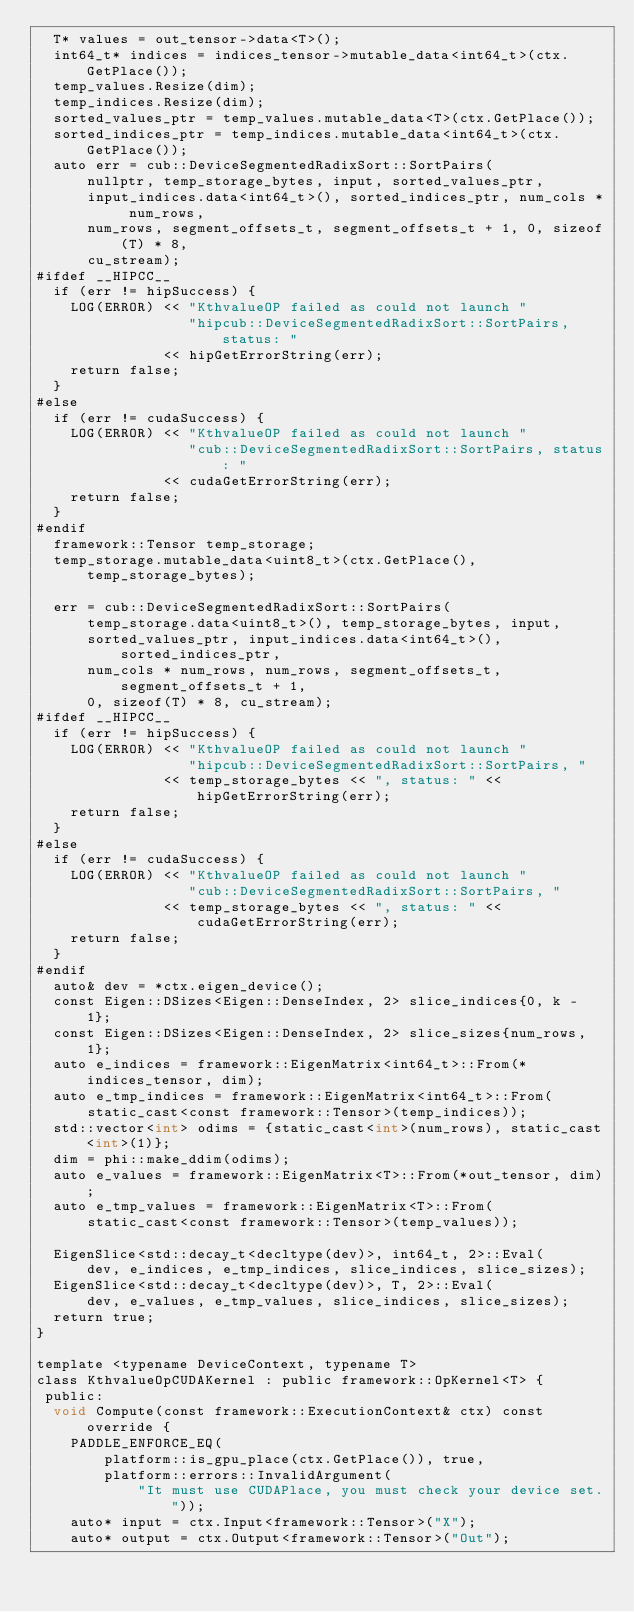<code> <loc_0><loc_0><loc_500><loc_500><_Cuda_>  T* values = out_tensor->data<T>();
  int64_t* indices = indices_tensor->mutable_data<int64_t>(ctx.GetPlace());
  temp_values.Resize(dim);
  temp_indices.Resize(dim);
  sorted_values_ptr = temp_values.mutable_data<T>(ctx.GetPlace());
  sorted_indices_ptr = temp_indices.mutable_data<int64_t>(ctx.GetPlace());
  auto err = cub::DeviceSegmentedRadixSort::SortPairs(
      nullptr, temp_storage_bytes, input, sorted_values_ptr,
      input_indices.data<int64_t>(), sorted_indices_ptr, num_cols * num_rows,
      num_rows, segment_offsets_t, segment_offsets_t + 1, 0, sizeof(T) * 8,
      cu_stream);
#ifdef __HIPCC__
  if (err != hipSuccess) {
    LOG(ERROR) << "KthvalueOP failed as could not launch "
                  "hipcub::DeviceSegmentedRadixSort::SortPairs, status: "
               << hipGetErrorString(err);
    return false;
  }
#else
  if (err != cudaSuccess) {
    LOG(ERROR) << "KthvalueOP failed as could not launch "
                  "cub::DeviceSegmentedRadixSort::SortPairs, status: "
               << cudaGetErrorString(err);
    return false;
  }
#endif
  framework::Tensor temp_storage;
  temp_storage.mutable_data<uint8_t>(ctx.GetPlace(), temp_storage_bytes);

  err = cub::DeviceSegmentedRadixSort::SortPairs(
      temp_storage.data<uint8_t>(), temp_storage_bytes, input,
      sorted_values_ptr, input_indices.data<int64_t>(), sorted_indices_ptr,
      num_cols * num_rows, num_rows, segment_offsets_t, segment_offsets_t + 1,
      0, sizeof(T) * 8, cu_stream);
#ifdef __HIPCC__
  if (err != hipSuccess) {
    LOG(ERROR) << "KthvalueOP failed as could not launch "
                  "hipcub::DeviceSegmentedRadixSort::SortPairs, "
               << temp_storage_bytes << ", status: " << hipGetErrorString(err);
    return false;
  }
#else
  if (err != cudaSuccess) {
    LOG(ERROR) << "KthvalueOP failed as could not launch "
                  "cub::DeviceSegmentedRadixSort::SortPairs, "
               << temp_storage_bytes << ", status: " << cudaGetErrorString(err);
    return false;
  }
#endif
  auto& dev = *ctx.eigen_device();
  const Eigen::DSizes<Eigen::DenseIndex, 2> slice_indices{0, k - 1};
  const Eigen::DSizes<Eigen::DenseIndex, 2> slice_sizes{num_rows, 1};
  auto e_indices = framework::EigenMatrix<int64_t>::From(*indices_tensor, dim);
  auto e_tmp_indices = framework::EigenMatrix<int64_t>::From(
      static_cast<const framework::Tensor>(temp_indices));
  std::vector<int> odims = {static_cast<int>(num_rows), static_cast<int>(1)};
  dim = phi::make_ddim(odims);
  auto e_values = framework::EigenMatrix<T>::From(*out_tensor, dim);
  auto e_tmp_values = framework::EigenMatrix<T>::From(
      static_cast<const framework::Tensor>(temp_values));

  EigenSlice<std::decay_t<decltype(dev)>, int64_t, 2>::Eval(
      dev, e_indices, e_tmp_indices, slice_indices, slice_sizes);
  EigenSlice<std::decay_t<decltype(dev)>, T, 2>::Eval(
      dev, e_values, e_tmp_values, slice_indices, slice_sizes);
  return true;
}

template <typename DeviceContext, typename T>
class KthvalueOpCUDAKernel : public framework::OpKernel<T> {
 public:
  void Compute(const framework::ExecutionContext& ctx) const override {
    PADDLE_ENFORCE_EQ(
        platform::is_gpu_place(ctx.GetPlace()), true,
        platform::errors::InvalidArgument(
            "It must use CUDAPlace, you must check your device set."));
    auto* input = ctx.Input<framework::Tensor>("X");
    auto* output = ctx.Output<framework::Tensor>("Out");</code> 